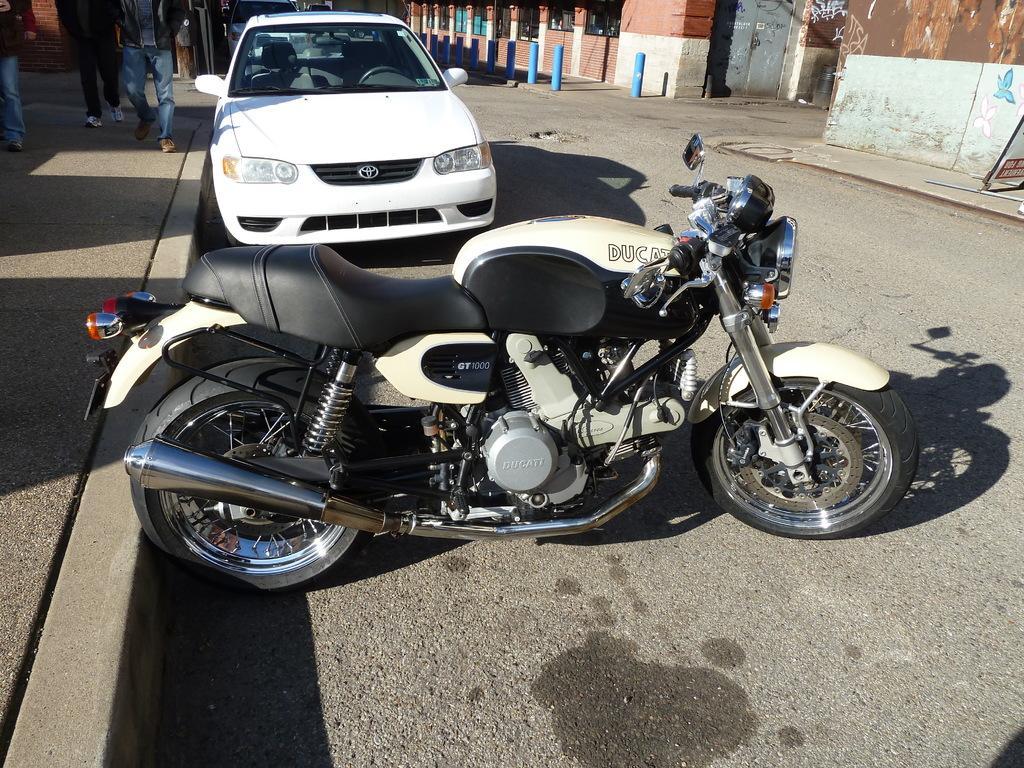Please provide a concise description of this image. In this picture there is a white and black color bike on the road in front of a white color car. On the left side there are three members walking on the footpath. On the right side there is a house and blue color poles. 